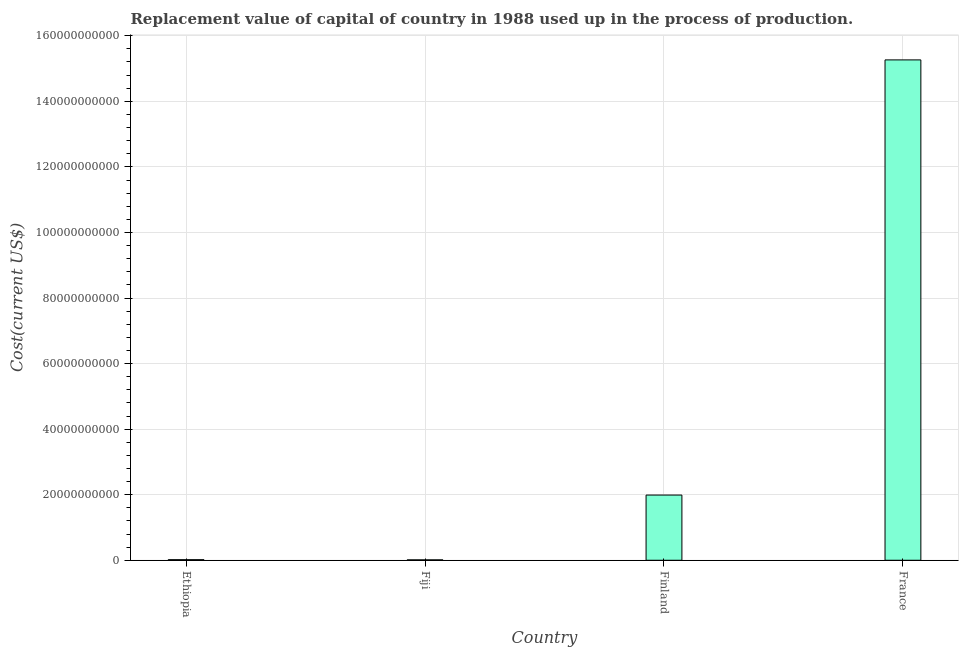Does the graph contain any zero values?
Your answer should be compact. No. What is the title of the graph?
Offer a terse response. Replacement value of capital of country in 1988 used up in the process of production. What is the label or title of the X-axis?
Offer a terse response. Country. What is the label or title of the Y-axis?
Ensure brevity in your answer.  Cost(current US$). What is the consumption of fixed capital in France?
Ensure brevity in your answer.  1.53e+11. Across all countries, what is the maximum consumption of fixed capital?
Offer a terse response. 1.53e+11. Across all countries, what is the minimum consumption of fixed capital?
Offer a very short reply. 1.24e+08. In which country was the consumption of fixed capital maximum?
Keep it short and to the point. France. In which country was the consumption of fixed capital minimum?
Keep it short and to the point. Fiji. What is the sum of the consumption of fixed capital?
Offer a very short reply. 1.73e+11. What is the difference between the consumption of fixed capital in Ethiopia and Finland?
Ensure brevity in your answer.  -1.97e+1. What is the average consumption of fixed capital per country?
Ensure brevity in your answer.  4.32e+1. What is the median consumption of fixed capital?
Give a very brief answer. 1.00e+1. What is the ratio of the consumption of fixed capital in Finland to that in France?
Provide a succinct answer. 0.13. What is the difference between the highest and the second highest consumption of fixed capital?
Keep it short and to the point. 1.33e+11. Is the sum of the consumption of fixed capital in Ethiopia and Finland greater than the maximum consumption of fixed capital across all countries?
Ensure brevity in your answer.  No. What is the difference between the highest and the lowest consumption of fixed capital?
Make the answer very short. 1.53e+11. In how many countries, is the consumption of fixed capital greater than the average consumption of fixed capital taken over all countries?
Provide a short and direct response. 1. How many bars are there?
Offer a very short reply. 4. How many countries are there in the graph?
Make the answer very short. 4. What is the difference between two consecutive major ticks on the Y-axis?
Provide a short and direct response. 2.00e+1. Are the values on the major ticks of Y-axis written in scientific E-notation?
Provide a succinct answer. No. What is the Cost(current US$) in Ethiopia?
Keep it short and to the point. 1.80e+08. What is the Cost(current US$) in Fiji?
Offer a very short reply. 1.24e+08. What is the Cost(current US$) in Finland?
Your answer should be compact. 1.99e+1. What is the Cost(current US$) of France?
Make the answer very short. 1.53e+11. What is the difference between the Cost(current US$) in Ethiopia and Fiji?
Ensure brevity in your answer.  5.64e+07. What is the difference between the Cost(current US$) in Ethiopia and Finland?
Your response must be concise. -1.97e+1. What is the difference between the Cost(current US$) in Ethiopia and France?
Ensure brevity in your answer.  -1.52e+11. What is the difference between the Cost(current US$) in Fiji and Finland?
Your answer should be compact. -1.98e+1. What is the difference between the Cost(current US$) in Fiji and France?
Offer a very short reply. -1.53e+11. What is the difference between the Cost(current US$) in Finland and France?
Provide a succinct answer. -1.33e+11. What is the ratio of the Cost(current US$) in Ethiopia to that in Fiji?
Your response must be concise. 1.46. What is the ratio of the Cost(current US$) in Ethiopia to that in Finland?
Ensure brevity in your answer.  0.01. What is the ratio of the Cost(current US$) in Ethiopia to that in France?
Provide a succinct answer. 0. What is the ratio of the Cost(current US$) in Fiji to that in Finland?
Keep it short and to the point. 0.01. What is the ratio of the Cost(current US$) in Fiji to that in France?
Ensure brevity in your answer.  0. What is the ratio of the Cost(current US$) in Finland to that in France?
Your answer should be compact. 0.13. 